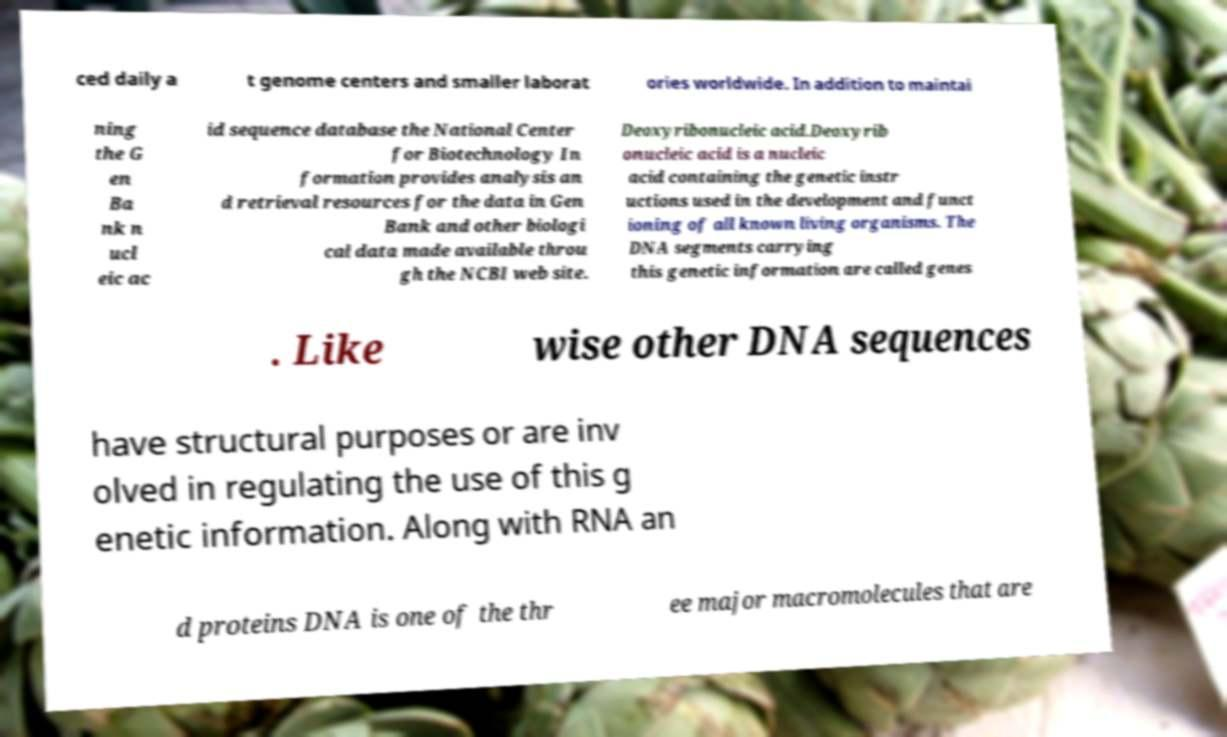What messages or text are displayed in this image? I need them in a readable, typed format. ced daily a t genome centers and smaller laborat ories worldwide. In addition to maintai ning the G en Ba nk n ucl eic ac id sequence database the National Center for Biotechnology In formation provides analysis an d retrieval resources for the data in Gen Bank and other biologi cal data made available throu gh the NCBI web site. Deoxyribonucleic acid.Deoxyrib onucleic acid is a nucleic acid containing the genetic instr uctions used in the development and funct ioning of all known living organisms. The DNA segments carrying this genetic information are called genes . Like wise other DNA sequences have structural purposes or are inv olved in regulating the use of this g enetic information. Along with RNA an d proteins DNA is one of the thr ee major macromolecules that are 